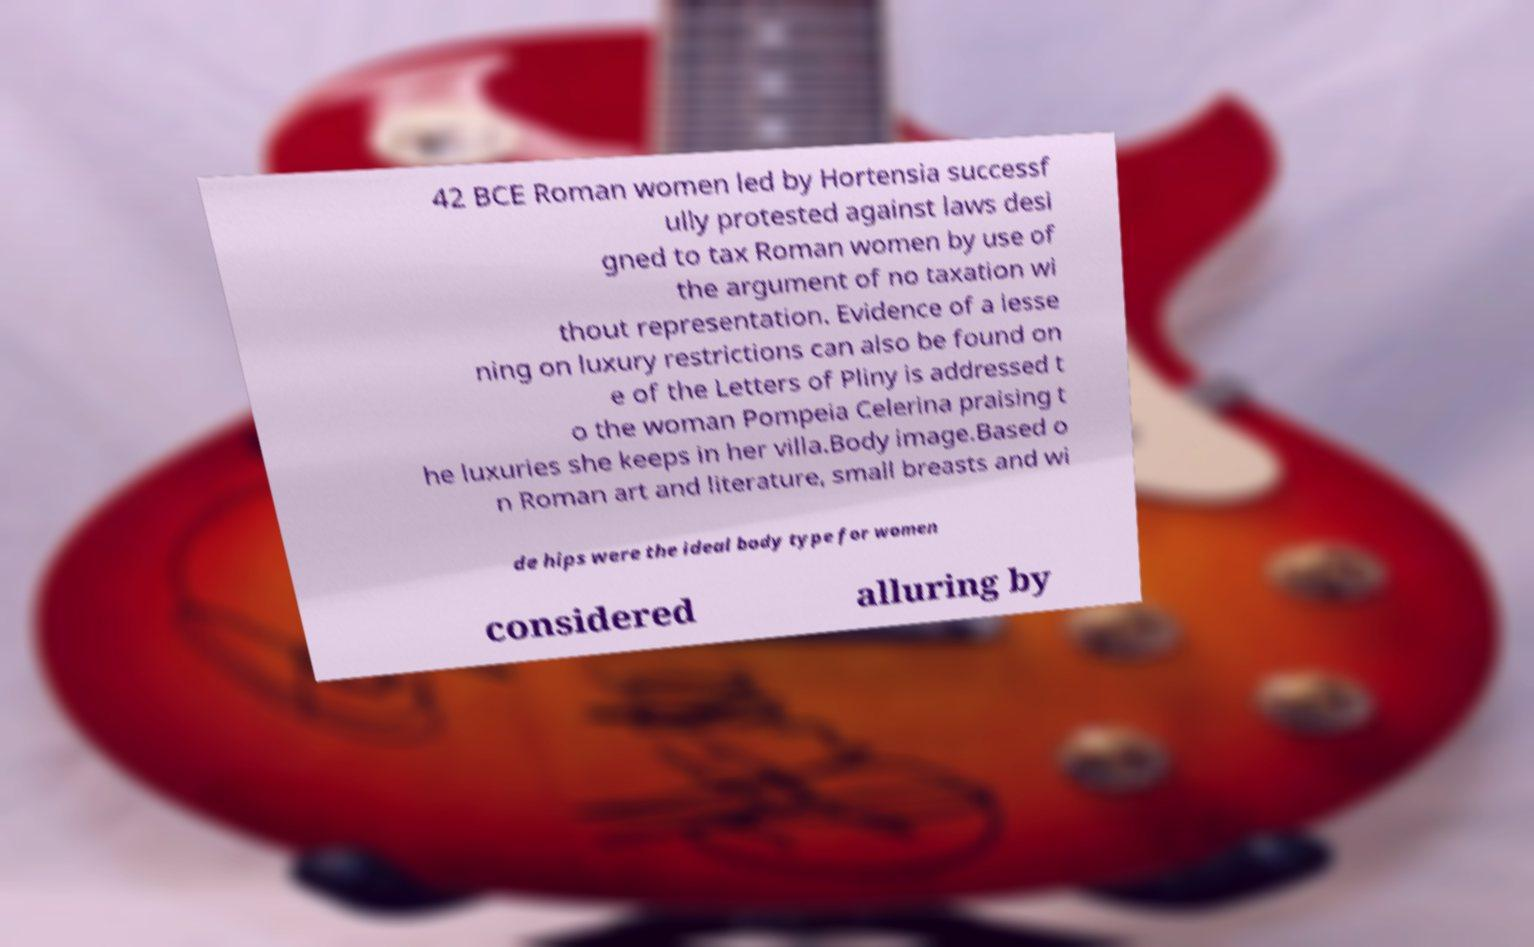Could you assist in decoding the text presented in this image and type it out clearly? 42 BCE Roman women led by Hortensia successf ully protested against laws desi gned to tax Roman women by use of the argument of no taxation wi thout representation. Evidence of a lesse ning on luxury restrictions can also be found on e of the Letters of Pliny is addressed t o the woman Pompeia Celerina praising t he luxuries she keeps in her villa.Body image.Based o n Roman art and literature, small breasts and wi de hips were the ideal body type for women considered alluring by 